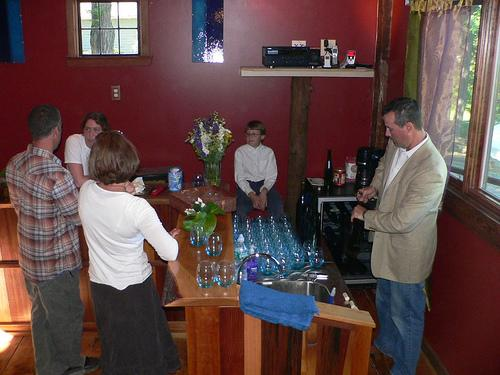What kind of interaction is taking place in this image? Casual conversation and interactions among friends or acquaintances in a bar. Identify the type and color of the room in the image. The room is a red bar or gathering space. What are the specific features of the man with the plaid shirt? The man with the plaid shirt is standing in a red room, and he is wearing grey jeans. Estimate the number of glasses in the image. There are at least ten glasses in the image. Analyze the sentiment of the scene in the image. The sentiment is positive and social, with people enjoying each other's company. What kind of clothing is one woman in the image wearing? One woman is wearing a white shirt and a long black skirt. How many people are in the image? There are five people in the image. What are the notable objects on the bar? A vase of flowers, blue cloth, glasses, and maybe a small refrigerator with a glass door. What is the primary activity happening in this image, and who is involved? People are socializing at a bar; a boy, two women, and two men are involved. Is there anything interesting outside the window in the image? There is a tree visible outside the window in the image. Do the bicycles leaning against the red wall catch your eye? No, it's not mentioned in the image. Identify and describe any objects related to drinks in the image. Glasses on the bar, clear blue glasses, bottle in man's hand, tall black bottle What are the colors of the room and flowers in the vase? Red room and purple and white flowers Notice the yellow ball rolling in front of the people. There is no mention of a yellow ball or any ball in the given information about the image, making this instruction misleading for those trying to find it. Identify the items on the bar and describe what the man in a tan suit is doing. Glasses, vase of flowers, blue cloth, man is holding a bottle Create a movie scene involving the image. A group of strangers, each with their unique stories, gather at a mysterious mixer party. Amidst the lively chatter, a soft-spoken boy in a white shirt sits cautiously next to the wolf statue, awaiting what the night unfolds. Determine any visible appliances in the image. A small refrigerator with a glass door Describe any electrical devices or components in the image. Electrical outlet on the wall, silver cordless phone What are the people in the image doing around the bar? People are standing and engaging with each other, man opening a bottle Is there a window in the image and if yes, what can be seen outside it? Yes, there is a window with a tree visible outside Which color can best represent the following objects: dish towel, jeans, and vase of flowers? Blue Come up with a short story based on the image. In a dimly lit red room filled with people, a boy nervously sits against a wolf, as others dressed in plaid shirts, white shirts, and tan suit coats enjoy a gathering by a bar adorned with glasses, a blue cloth, and a vase of purple and white flowers. What is the boy in the image doing, and what is the setting he is in? The boy is sitting against a wolf, and he is in a red room with people around Imagine walking into the scene. Describe the scene as if you were a narrator. In a cozy red room, five people gather around a bar filled with a variety of glasses and a vase of flowers. The boy sits quietly by a life-sized wolf statue, listening to the hum of conversations around a man opening a bottle. Select the correct description of the image: a) a beige blazer, a man opening a brown bottle, and a small silver sink b) a woman in a red dress sitting on a couch, a lamp on a side table, two children playing c) a kitchen with a wooden table, plates, and bowls on the counters, woman cooking at the stove a) a beige blazer, a man opening a brown bottle, and a small silver sink Identify the clothes worn by the people in the image. White shirt, plaid shirt, white short sleeve shirt, tan suit coat, blue pants, man's brown blazer, blue jeans, long black skirt, grey jeans Determine if there is any relevant text in the image that can be used for OCR. No relevant text for OCR Multiple choice options: which object is placed on the armrest: a) a blue dish towel b) a brown plate c) an orange cushion a) a blue dish towel Describe the emotions expressed by various people in the image. Cannot determine from the given information 